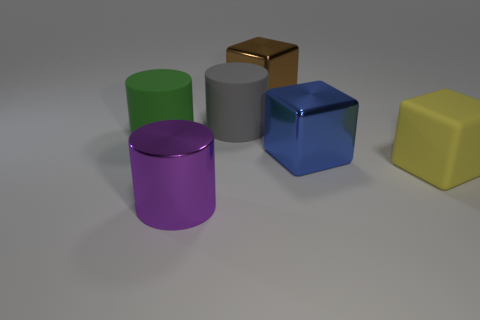How many big gray cylinders are right of the big blue thing?
Provide a succinct answer. 0. Does the large brown metal object have the same shape as the rubber thing that is in front of the big green rubber object?
Offer a terse response. Yes. Is there another big matte object that has the same shape as the large green object?
Keep it short and to the point. Yes. The big thing to the left of the big metallic thing to the left of the gray rubber cylinder is what shape?
Make the answer very short. Cylinder. There is a large rubber object left of the purple metallic object; what shape is it?
Provide a succinct answer. Cylinder. Does the metallic object that is to the left of the large brown cube have the same color as the rubber thing that is on the left side of the big purple cylinder?
Your response must be concise. No. What number of large things are to the left of the big brown shiny cube and behind the big blue block?
Offer a very short reply. 2. The purple object that is made of the same material as the big brown thing is what size?
Offer a terse response. Large. What size is the green cylinder?
Give a very brief answer. Large. What material is the gray cylinder?
Your answer should be very brief. Rubber. 